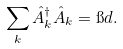Convert formula to latex. <formula><loc_0><loc_0><loc_500><loc_500>\sum _ { k } { \hat { A } } ^ { \dagger } _ { k } { \hat { A } } _ { k } = { \i d } .</formula> 